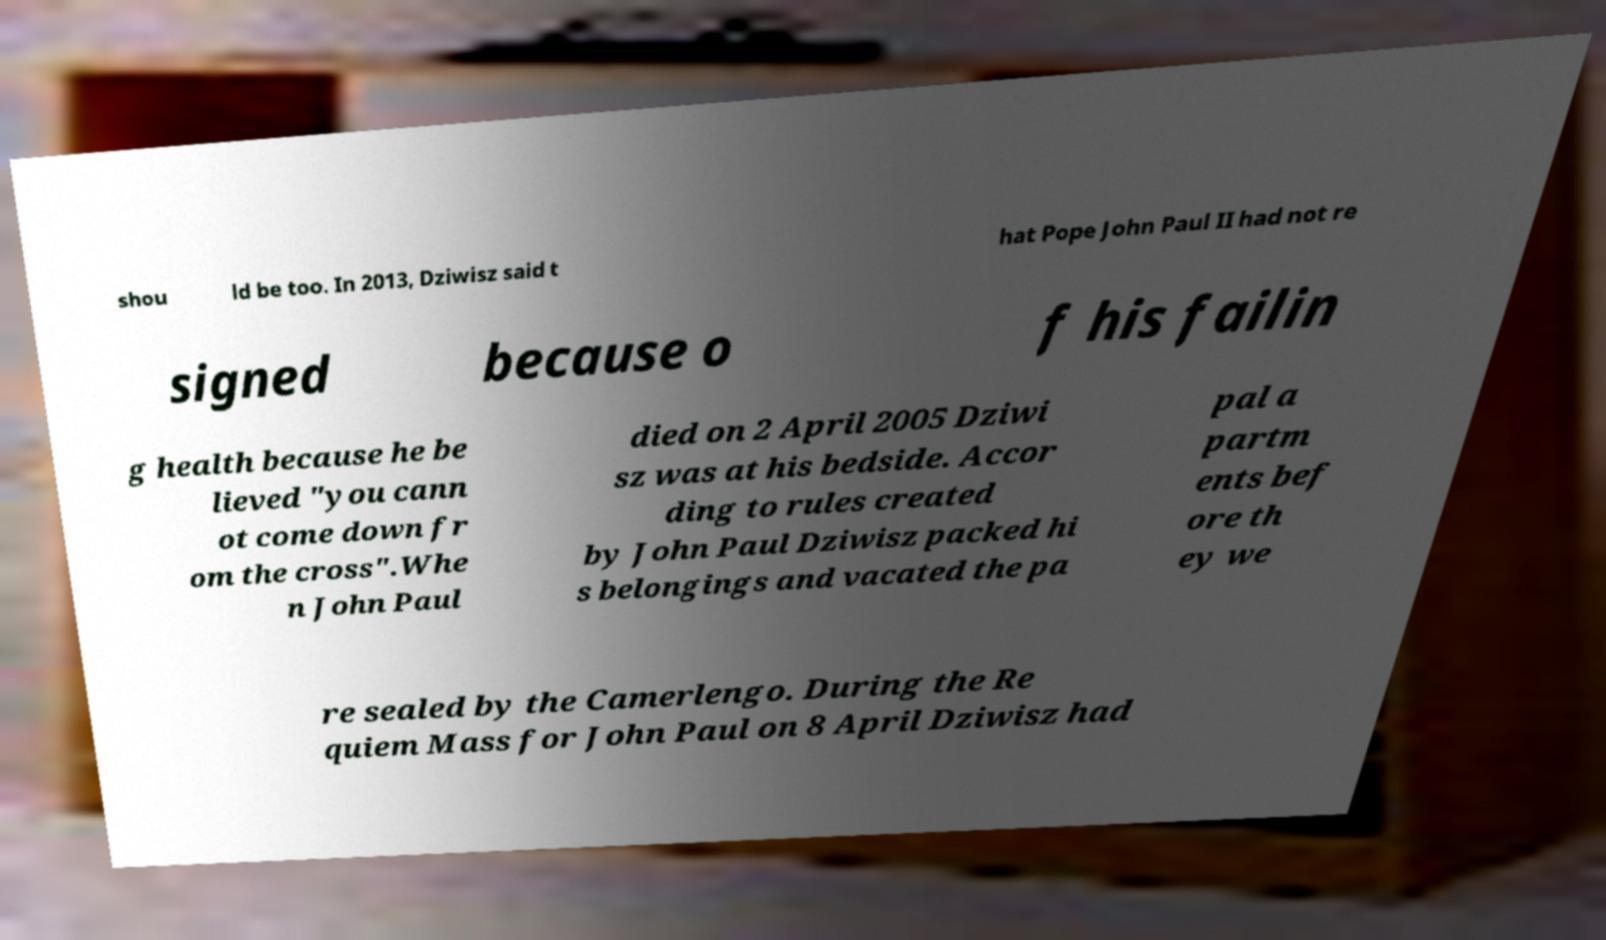Can you read and provide the text displayed in the image?This photo seems to have some interesting text. Can you extract and type it out for me? shou ld be too. In 2013, Dziwisz said t hat Pope John Paul II had not re signed because o f his failin g health because he be lieved "you cann ot come down fr om the cross".Whe n John Paul died on 2 April 2005 Dziwi sz was at his bedside. Accor ding to rules created by John Paul Dziwisz packed hi s belongings and vacated the pa pal a partm ents bef ore th ey we re sealed by the Camerlengo. During the Re quiem Mass for John Paul on 8 April Dziwisz had 